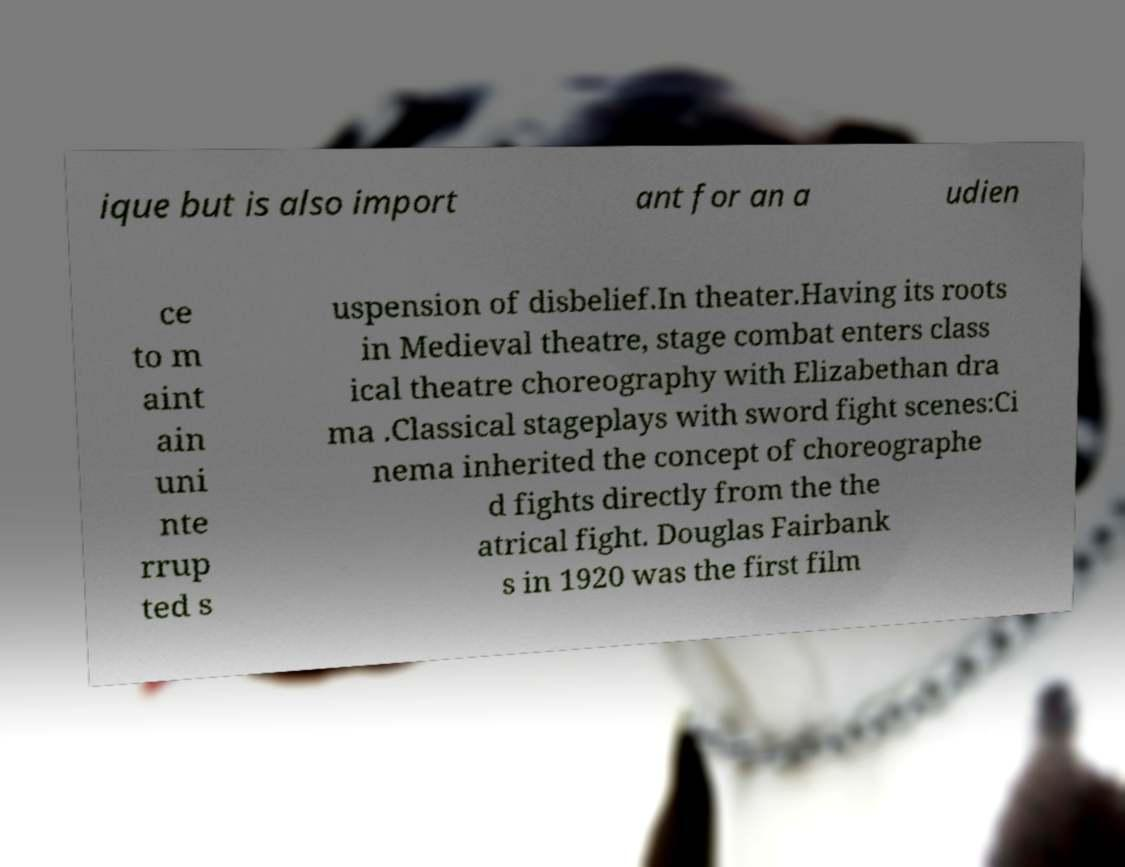Can you accurately transcribe the text from the provided image for me? ique but is also import ant for an a udien ce to m aint ain uni nte rrup ted s uspension of disbelief.In theater.Having its roots in Medieval theatre, stage combat enters class ical theatre choreography with Elizabethan dra ma .Classical stageplays with sword fight scenes:Ci nema inherited the concept of choreographe d fights directly from the the atrical fight. Douglas Fairbank s in 1920 was the first film 